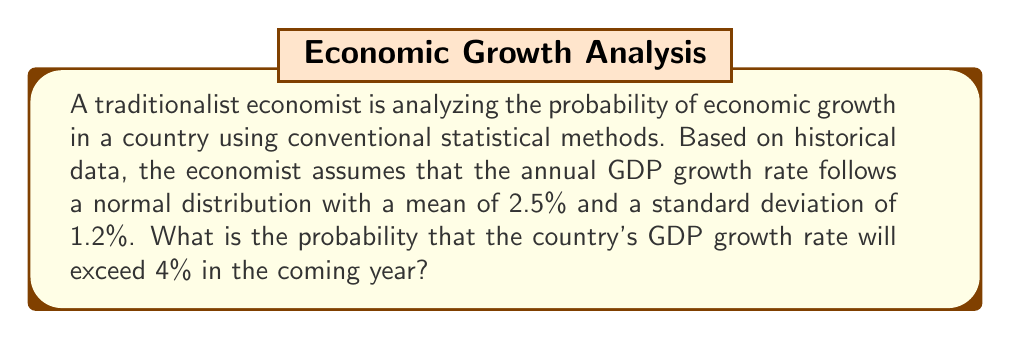Provide a solution to this math problem. To solve this problem, we'll use the traditional statistical method of working with the normal distribution. We'll follow these steps:

1) First, we need to standardize our value to calculate the z-score. The z-score formula is:

   $$z = \frac{x - \mu}{\sigma}$$

   Where:
   $x$ is the value we're interested in (4%)
   $\mu$ is the mean (2.5%)
   $\sigma$ is the standard deviation (1.2%)

2) Let's calculate the z-score:

   $$z = \frac{4 - 2.5}{1.2} = \frac{1.5}{1.2} = 1.25$$

3) Now that we have the z-score, we need to find the area to the right of this z-score in the standard normal distribution table. This area represents the probability of the GDP growth rate exceeding 4%.

4) Using a standard normal distribution table, we find that the area to the right of z = 1.25 is approximately 0.1056.

5) Therefore, the probability of the GDP growth rate exceeding 4% is about 0.1056 or 10.56%.

This traditional approach assumes that economic growth follows a normal distribution and relies on historical data to estimate the parameters of this distribution. It doesn't account for potential structural changes or external shocks that might affect future economic performance.
Answer: The probability that the country's GDP growth rate will exceed 4% in the coming year is approximately 0.1056 or 10.56%. 